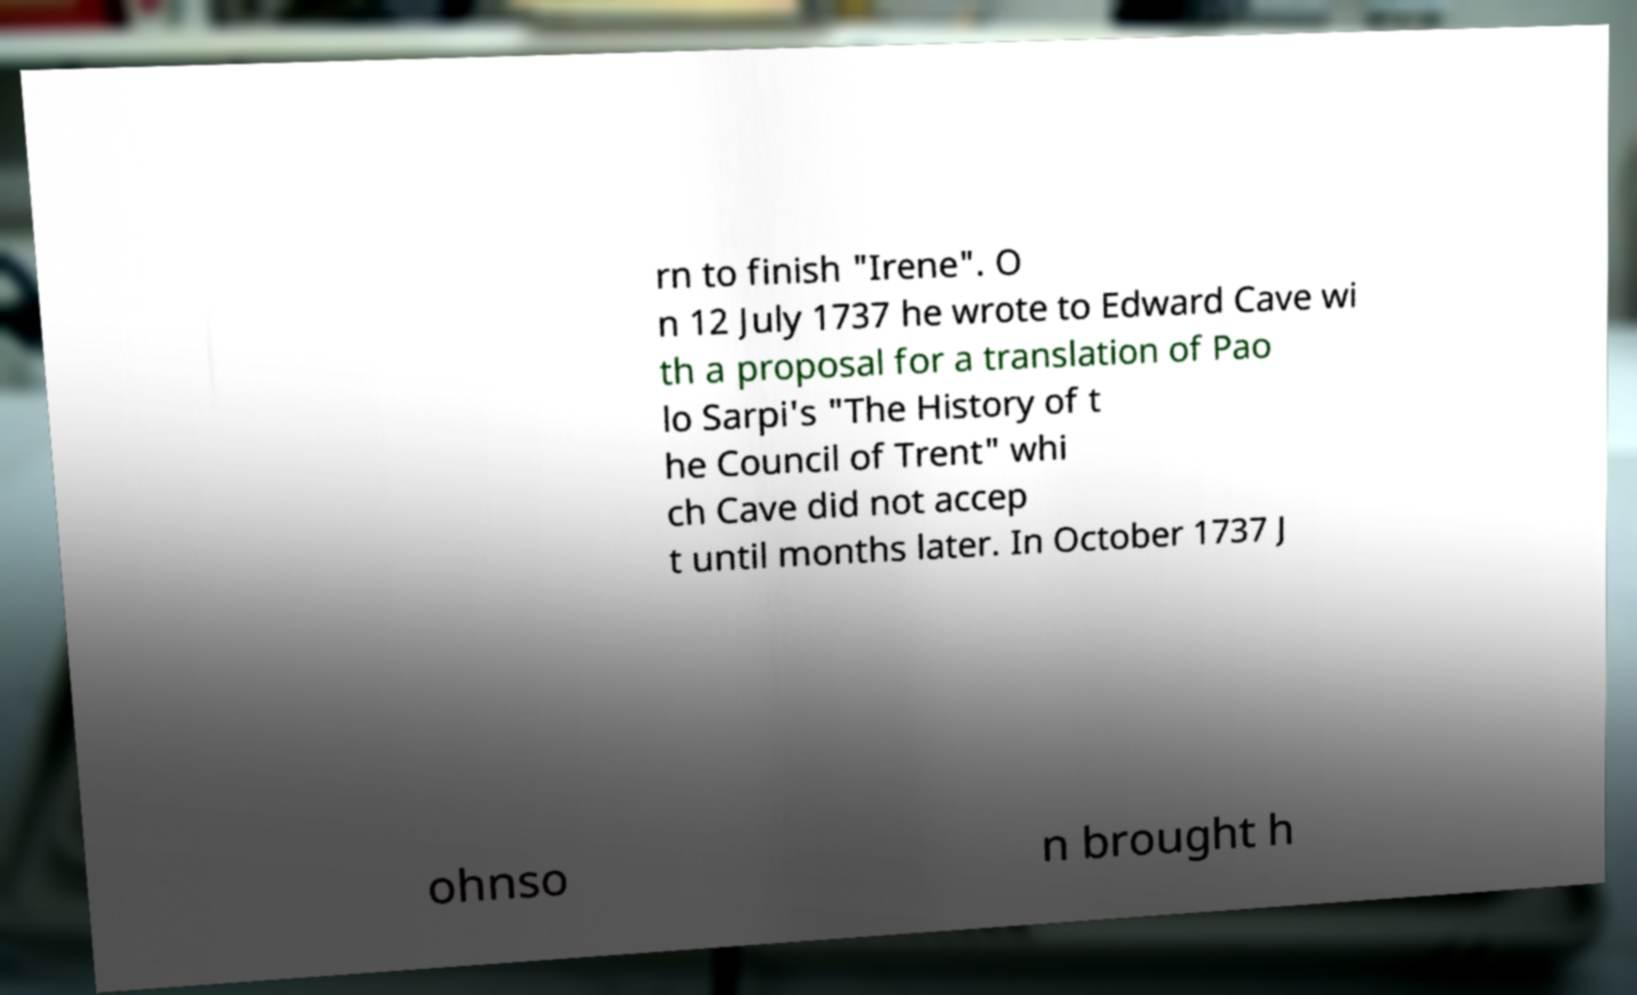There's text embedded in this image that I need extracted. Can you transcribe it verbatim? rn to finish "Irene". O n 12 July 1737 he wrote to Edward Cave wi th a proposal for a translation of Pao lo Sarpi's "The History of t he Council of Trent" whi ch Cave did not accep t until months later. In October 1737 J ohnso n brought h 